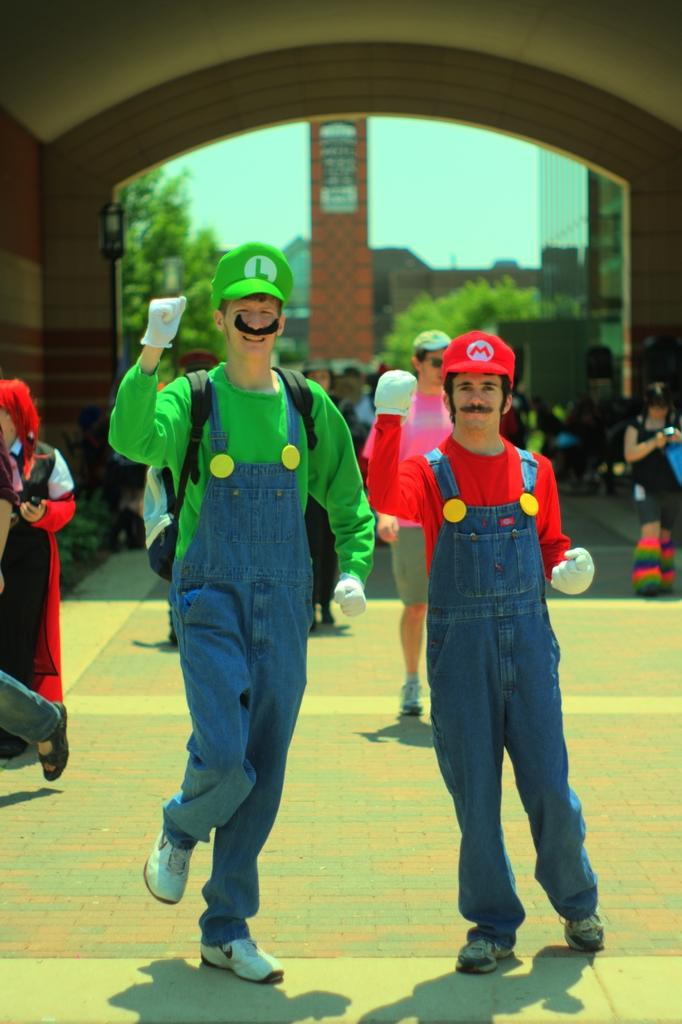What can be seen in the front of the image? There are persons standing in the front of the image. What is the facial expression of the persons in the image? The persons are smiling. What is located in the background of the image? There is an arch, trees, persons, and buildings in the background of the image. What type of apple is being used by the beginner in the image? There is no apple or beginner present in the image. What color is the coat worn by the person in the image? There is no coat visible in the image; the persons are not wearing any outerwear. 